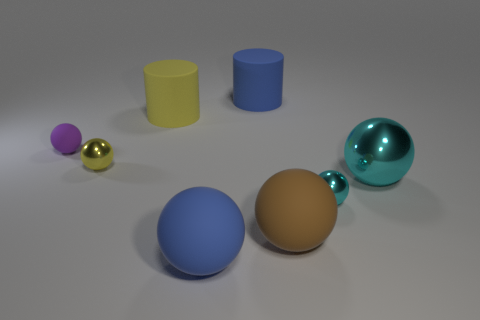Are there any metallic things right of the large metal object?
Ensure brevity in your answer.  No. Are there the same number of cyan metallic things on the left side of the small rubber thing and cylinders?
Offer a very short reply. No. What is the size of the other cyan object that is the same shape as the large cyan metallic object?
Keep it short and to the point. Small. There is a small cyan object; is its shape the same as the purple matte object to the left of the blue rubber sphere?
Keep it short and to the point. Yes. There is a purple rubber object that is left of the sphere that is in front of the brown thing; how big is it?
Give a very brief answer. Small. Are there an equal number of shiny things left of the yellow metal thing and cyan balls in front of the large cyan metallic ball?
Offer a very short reply. No. There is another large object that is the same shape as the large yellow matte thing; what color is it?
Keep it short and to the point. Blue. What number of shiny balls are the same color as the big metallic object?
Your answer should be very brief. 1. There is a large blue matte object in front of the tiny rubber ball; is its shape the same as the small cyan metallic thing?
Your answer should be very brief. Yes. What shape is the shiny thing behind the big thing on the right side of the tiny shiny ball that is in front of the big cyan shiny thing?
Keep it short and to the point. Sphere. 